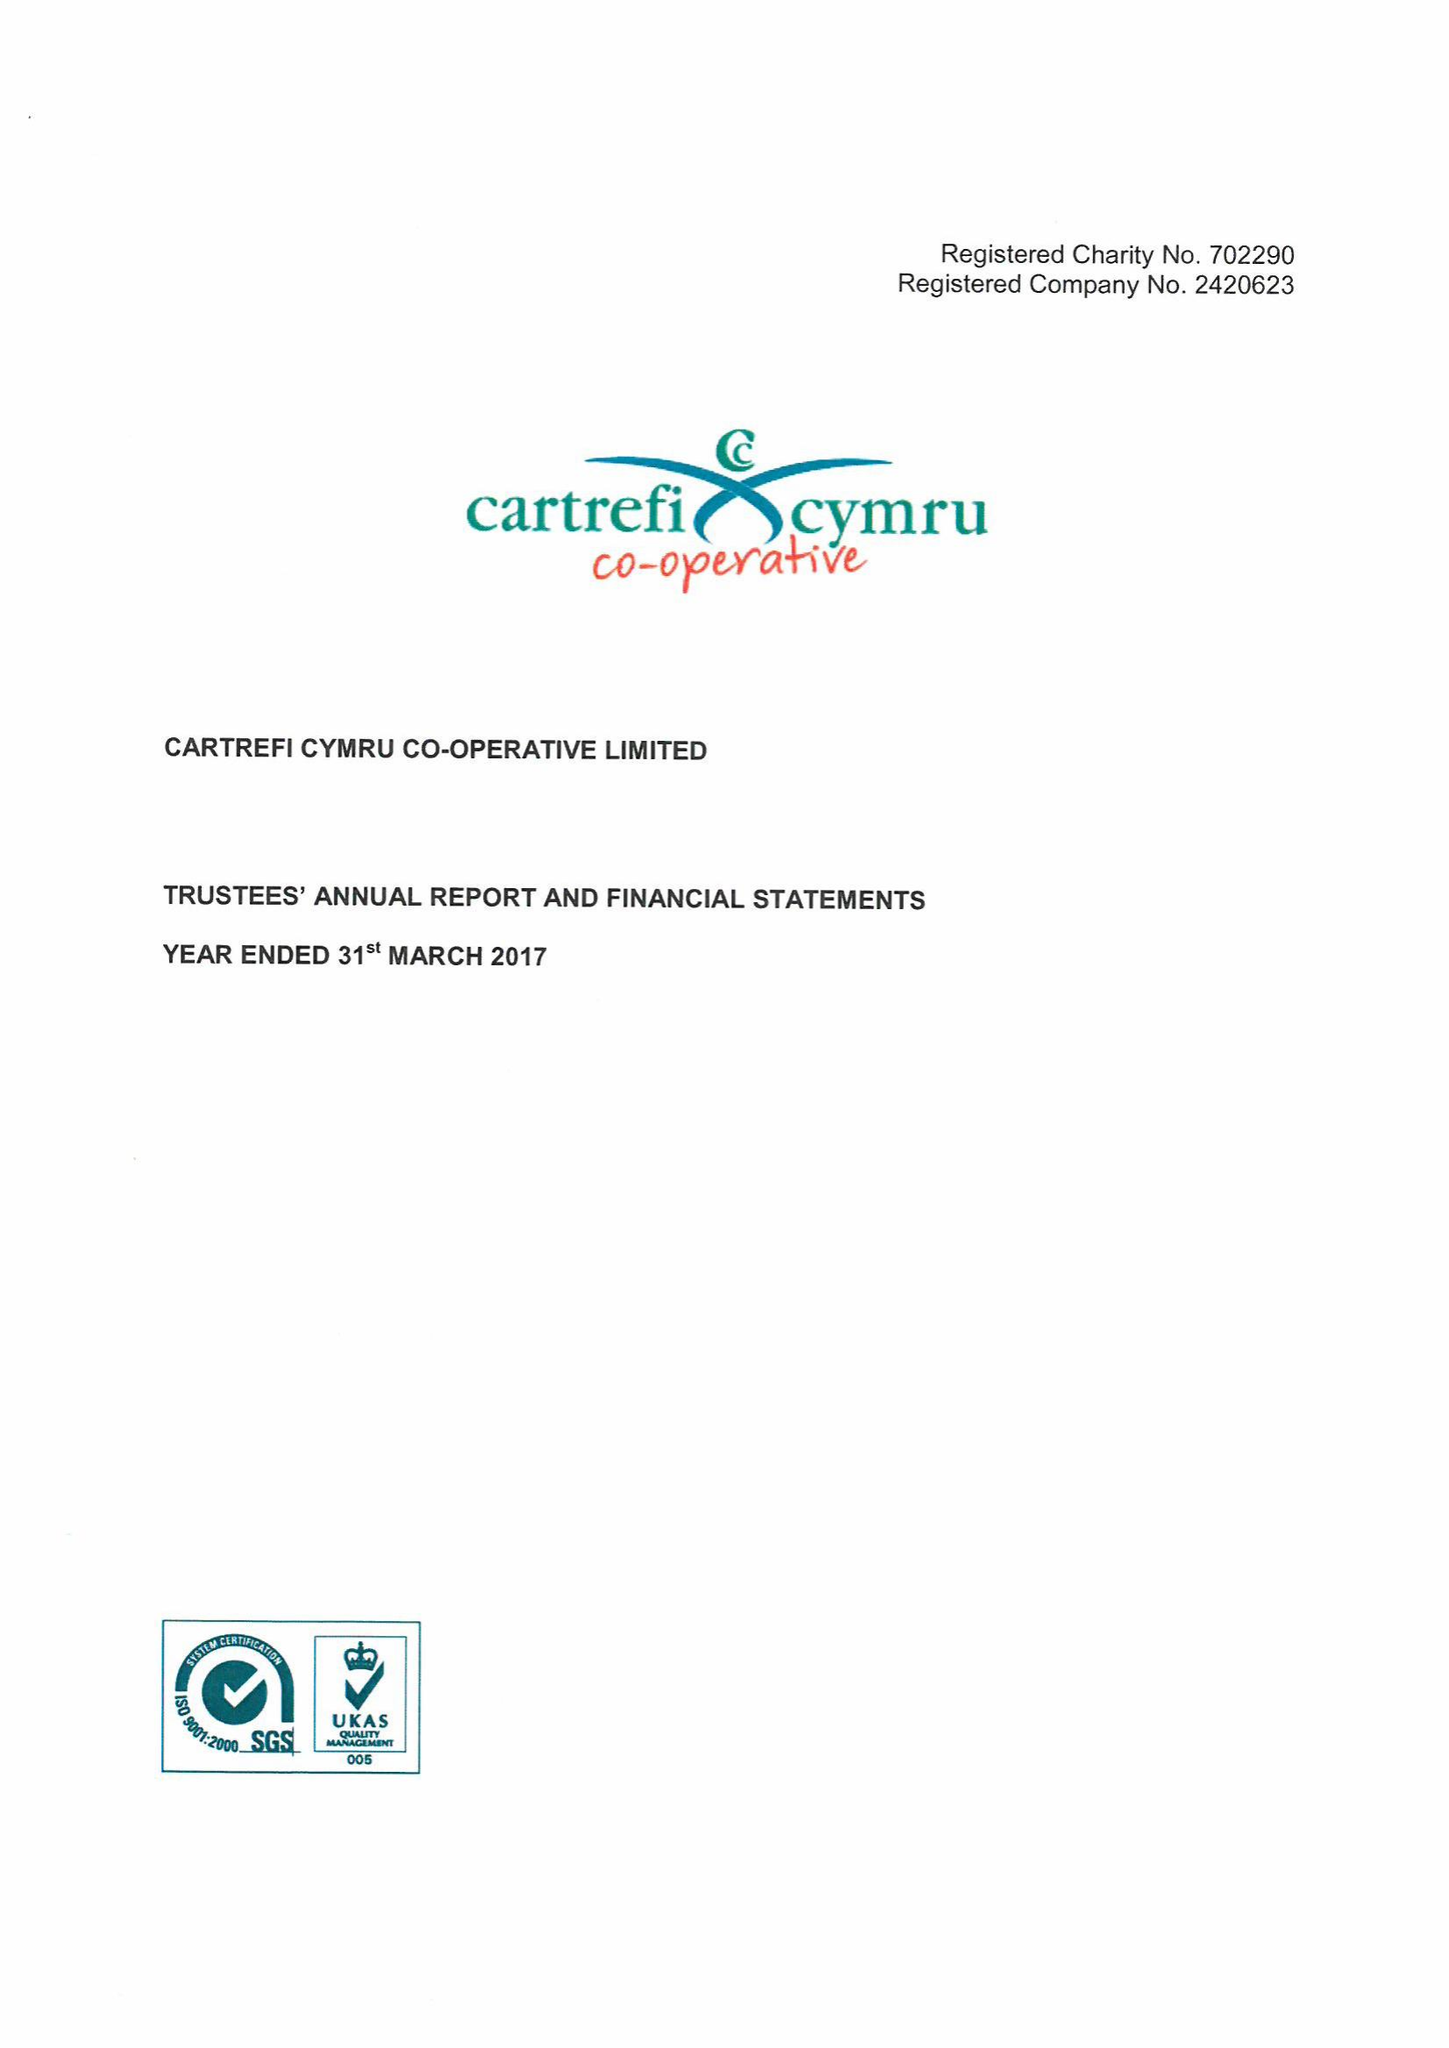What is the value for the address__street_line?
Answer the question using a single word or phrase. CURRAN ROAD 